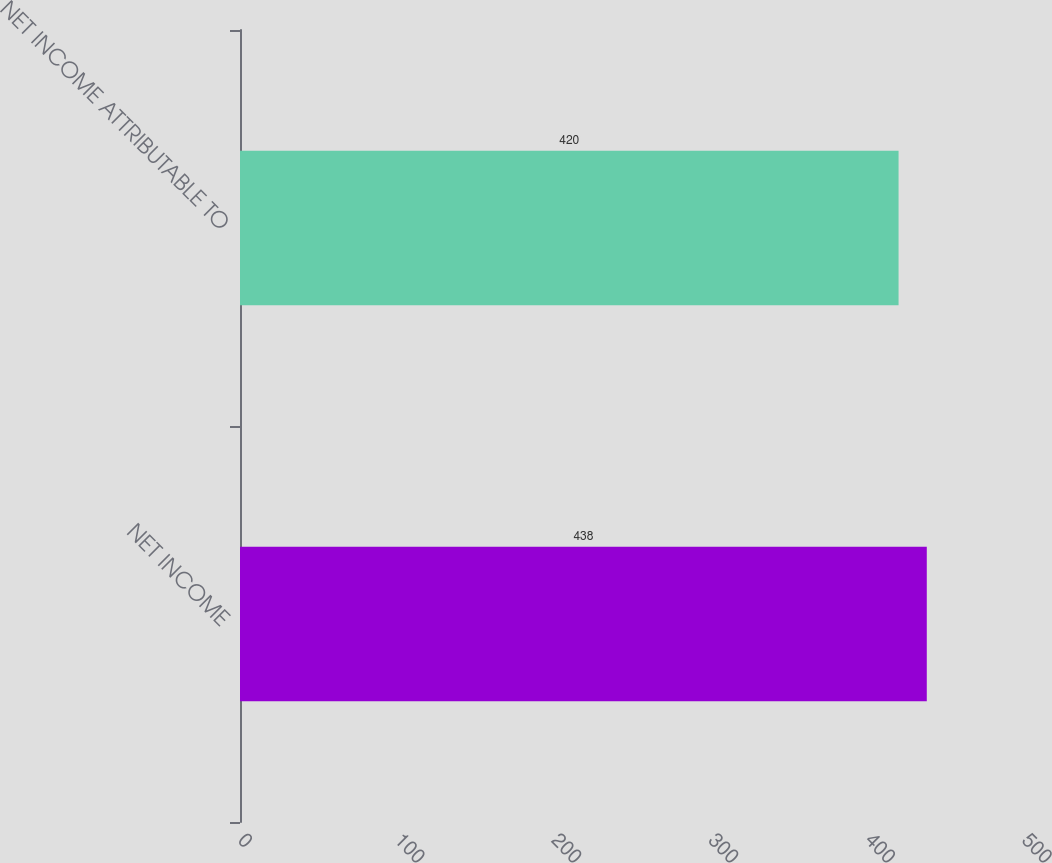Convert chart. <chart><loc_0><loc_0><loc_500><loc_500><bar_chart><fcel>NET INCOME<fcel>NET INCOME ATTRIBUTABLE TO<nl><fcel>438<fcel>420<nl></chart> 